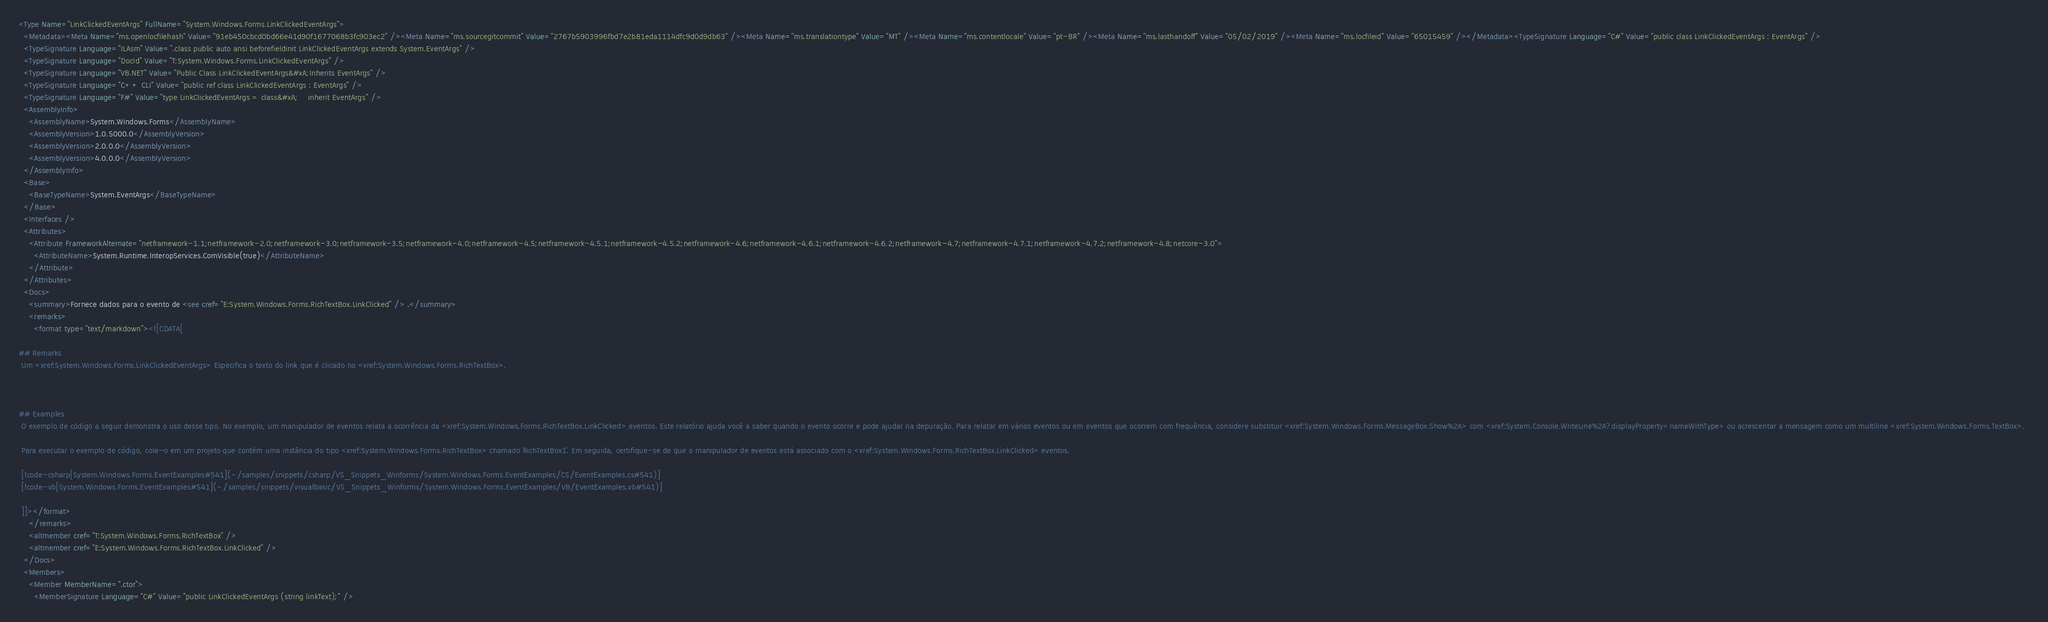Convert code to text. <code><loc_0><loc_0><loc_500><loc_500><_XML_><Type Name="LinkClickedEventArgs" FullName="System.Windows.Forms.LinkClickedEventArgs">
  <Metadata><Meta Name="ms.openlocfilehash" Value="91eb450cbcd0bd66e41d90f1677068b3fc903ec2" /><Meta Name="ms.sourcegitcommit" Value="2767b5903996fbd7e2b81eda1114dfc9d0d9db63" /><Meta Name="ms.translationtype" Value="MT" /><Meta Name="ms.contentlocale" Value="pt-BR" /><Meta Name="ms.lasthandoff" Value="05/02/2019" /><Meta Name="ms.locfileid" Value="65015459" /></Metadata><TypeSignature Language="C#" Value="public class LinkClickedEventArgs : EventArgs" />
  <TypeSignature Language="ILAsm" Value=".class public auto ansi beforefieldinit LinkClickedEventArgs extends System.EventArgs" />
  <TypeSignature Language="DocId" Value="T:System.Windows.Forms.LinkClickedEventArgs" />
  <TypeSignature Language="VB.NET" Value="Public Class LinkClickedEventArgs&#xA;Inherits EventArgs" />
  <TypeSignature Language="C++ CLI" Value="public ref class LinkClickedEventArgs : EventArgs" />
  <TypeSignature Language="F#" Value="type LinkClickedEventArgs = class&#xA;    inherit EventArgs" />
  <AssemblyInfo>
    <AssemblyName>System.Windows.Forms</AssemblyName>
    <AssemblyVersion>1.0.5000.0</AssemblyVersion>
    <AssemblyVersion>2.0.0.0</AssemblyVersion>
    <AssemblyVersion>4.0.0.0</AssemblyVersion>
  </AssemblyInfo>
  <Base>
    <BaseTypeName>System.EventArgs</BaseTypeName>
  </Base>
  <Interfaces />
  <Attributes>
    <Attribute FrameworkAlternate="netframework-1.1;netframework-2.0;netframework-3.0;netframework-3.5;netframework-4.0;netframework-4.5;netframework-4.5.1;netframework-4.5.2;netframework-4.6;netframework-4.6.1;netframework-4.6.2;netframework-4.7;netframework-4.7.1;netframework-4.7.2;netframework-4.8;netcore-3.0">
      <AttributeName>System.Runtime.InteropServices.ComVisible(true)</AttributeName>
    </Attribute>
  </Attributes>
  <Docs>
    <summary>Fornece dados para o evento de <see cref="E:System.Windows.Forms.RichTextBox.LinkClicked" /> .</summary>
    <remarks>
      <format type="text/markdown"><![CDATA[  
  
## Remarks  
 Um <xref:System.Windows.Forms.LinkClickedEventArgs> Especifica o texto do link que é clicado no <xref:System.Windows.Forms.RichTextBox>.  
  
   
  
## Examples  
 O exemplo de código a seguir demonstra o uso desse tipo. No exemplo, um manipulador de eventos relata a ocorrência da <xref:System.Windows.Forms.RichTextBox.LinkClicked> eventos. Este relatório ajuda você a saber quando o evento ocorre e pode ajudar na depuração. Para relatar em vários eventos ou em eventos que ocorrem com frequência, considere substituir <xref:System.Windows.Forms.MessageBox.Show%2A> com <xref:System.Console.WriteLine%2A?displayProperty=nameWithType> ou acrescentar a mensagem como um multiline <xref:System.Windows.Forms.TextBox>.  
  
 Para executar o exemplo de código, cole-o em um projeto que contém uma instância do tipo <xref:System.Windows.Forms.RichTextBox> chamado `RichTextBox1`. Em seguida, certifique-se de que o manipulador de eventos está associado com o <xref:System.Windows.Forms.RichTextBox.LinkClicked> eventos.  
  
 [!code-csharp[System.Windows.Forms.EventExamples#541](~/samples/snippets/csharp/VS_Snippets_Winforms/System.Windows.Forms.EventExamples/CS/EventExamples.cs#541)]
 [!code-vb[System.Windows.Forms.EventExamples#541](~/samples/snippets/visualbasic/VS_Snippets_Winforms/System.Windows.Forms.EventExamples/VB/EventExamples.vb#541)]  
  
 ]]></format>
    </remarks>
    <altmember cref="T:System.Windows.Forms.RichTextBox" />
    <altmember cref="E:System.Windows.Forms.RichTextBox.LinkClicked" />
  </Docs>
  <Members>
    <Member MemberName=".ctor">
      <MemberSignature Language="C#" Value="public LinkClickedEventArgs (string linkText);" /></code> 